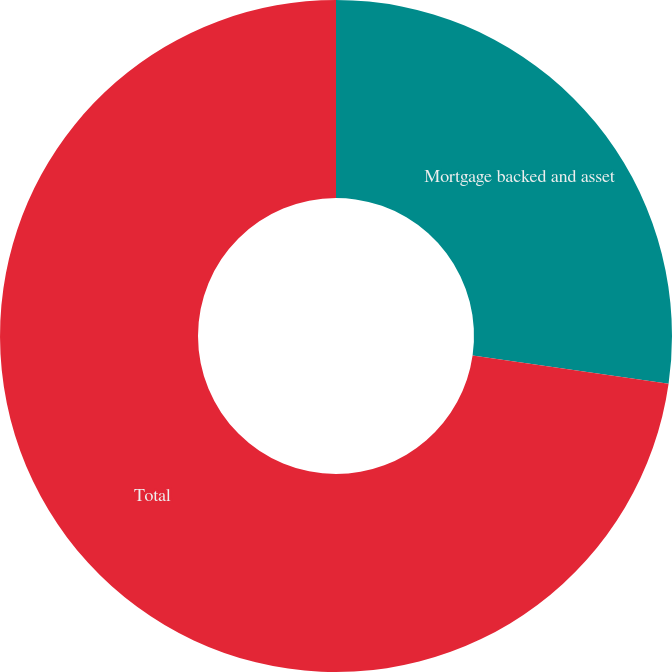<chart> <loc_0><loc_0><loc_500><loc_500><pie_chart><fcel>Mortgage backed and asset<fcel>Total<nl><fcel>27.27%<fcel>72.73%<nl></chart> 